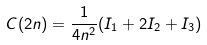Convert formula to latex. <formula><loc_0><loc_0><loc_500><loc_500>C ( 2 n ) = \frac { 1 } { 4 n ^ { 2 } } ( I _ { 1 } + 2 I _ { 2 } + I _ { 3 } )</formula> 